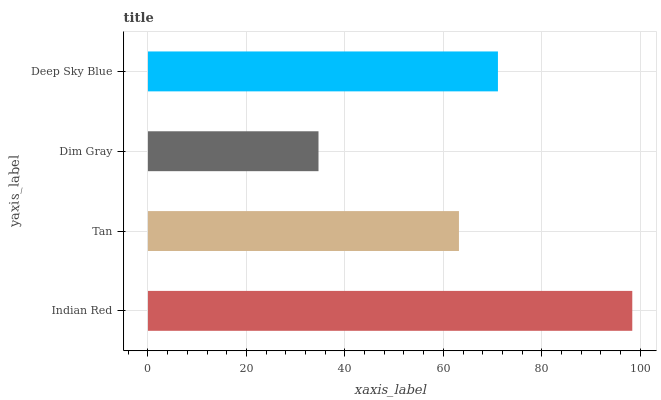Is Dim Gray the minimum?
Answer yes or no. Yes. Is Indian Red the maximum?
Answer yes or no. Yes. Is Tan the minimum?
Answer yes or no. No. Is Tan the maximum?
Answer yes or no. No. Is Indian Red greater than Tan?
Answer yes or no. Yes. Is Tan less than Indian Red?
Answer yes or no. Yes. Is Tan greater than Indian Red?
Answer yes or no. No. Is Indian Red less than Tan?
Answer yes or no. No. Is Deep Sky Blue the high median?
Answer yes or no. Yes. Is Tan the low median?
Answer yes or no. Yes. Is Indian Red the high median?
Answer yes or no. No. Is Dim Gray the low median?
Answer yes or no. No. 